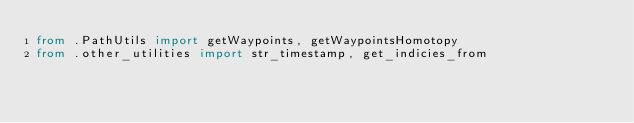<code> <loc_0><loc_0><loc_500><loc_500><_Python_>from .PathUtils import getWaypoints, getWaypointsHomotopy
from .other_utilities import str_timestamp, get_indicies_from
</code> 